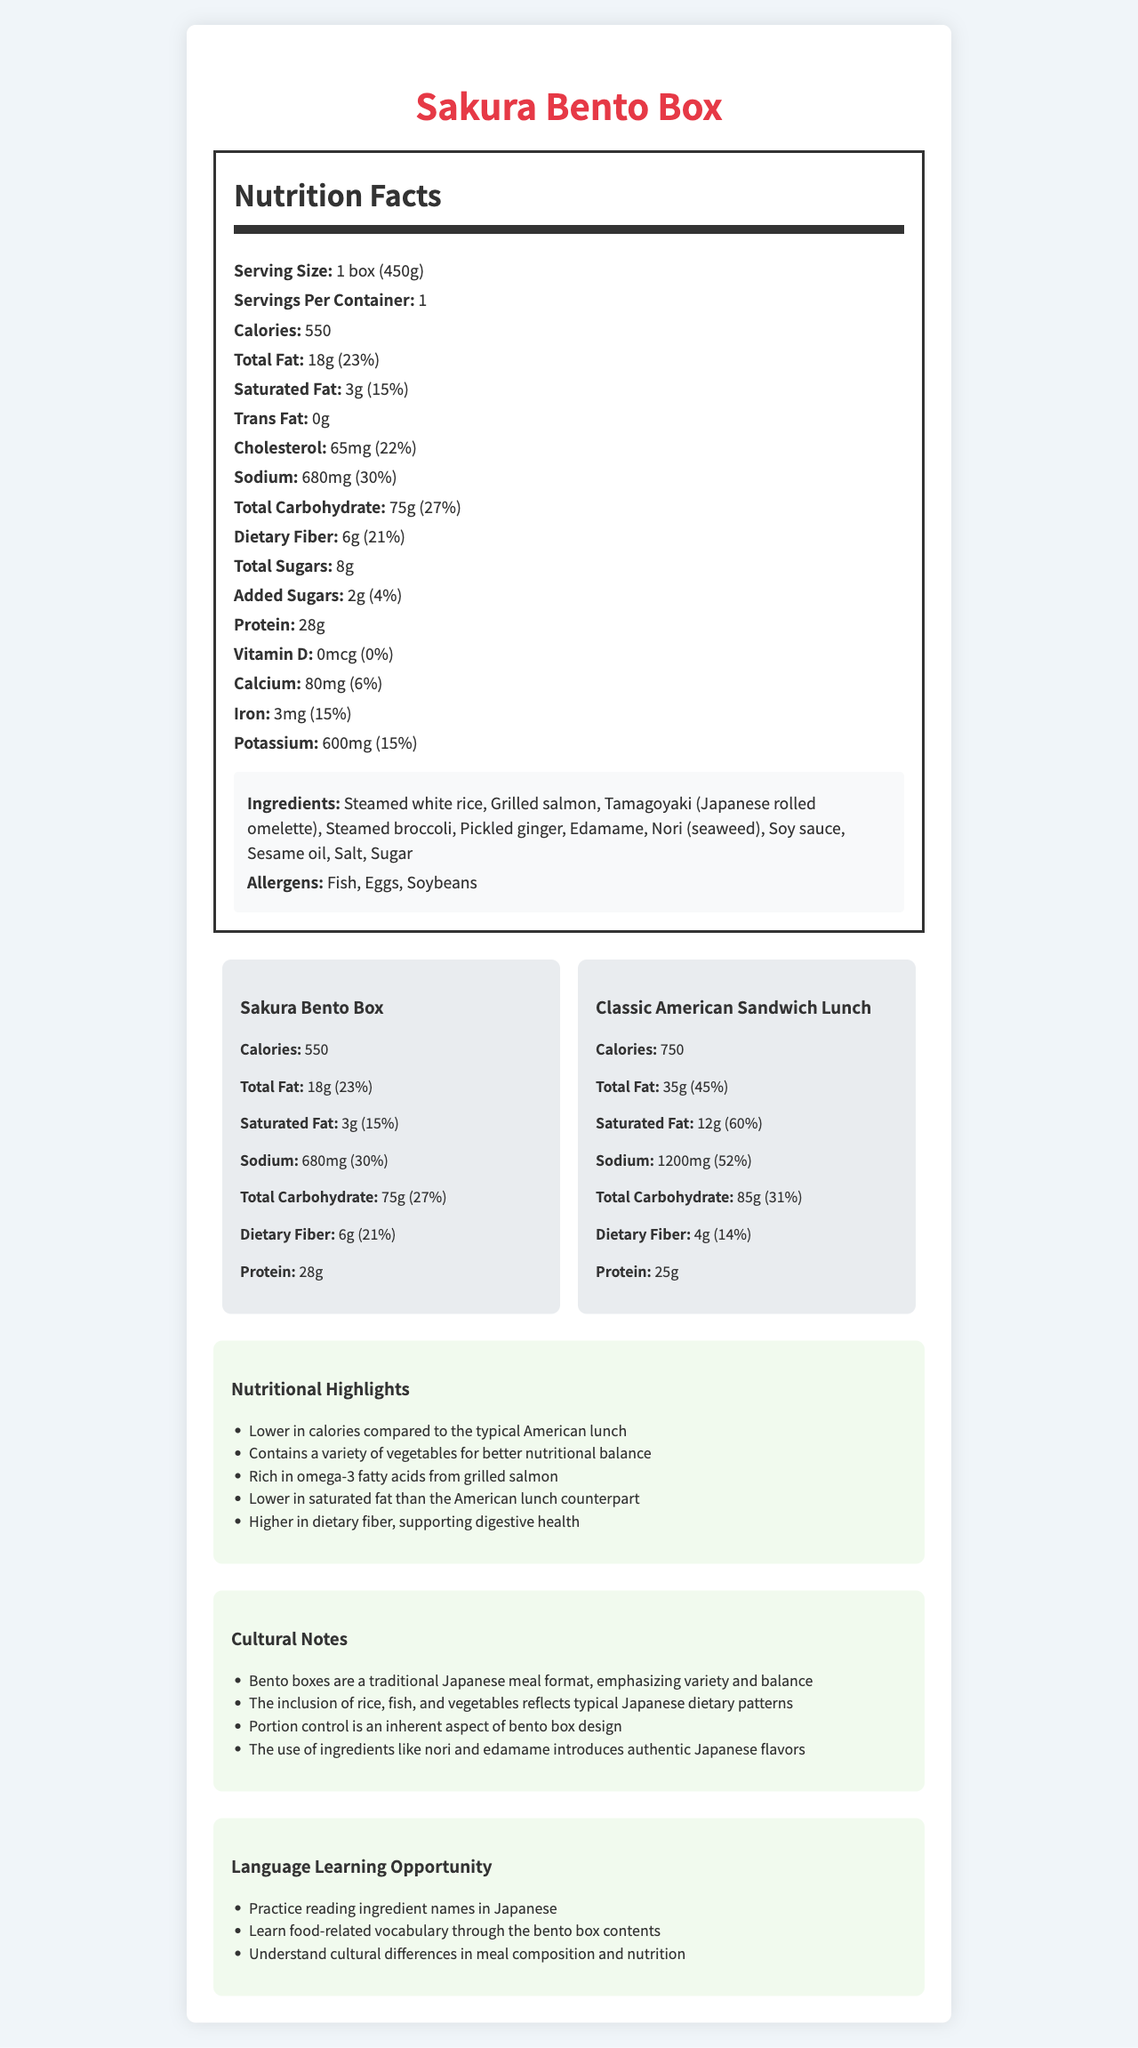what is the serving size of the Sakura Bento Box? The serving size is explicitly mentioned as "1 box (450g)" in the document.
Answer: 1 box (450g) how many calories does the Sakura Bento Box contain? The calories for the Sakura Bento Box are listed as 550 in the Nutrition Facts section.
Answer: 550 what is the protein content in the Sakura Bento Box? The protein content of the Sakura Bento Box is specified as 28g.
Answer: 28g list all the allergens present in the Sakura Bento Box. The allergens listed for the Sakura Bento Box are Fish, Eggs, and Soybeans.
Answer: Fish, Eggs, Soybeans how much dietary fiber does the Sakura Bento Box have? The dietary fiber content is given as 6g.
Answer: 6g compare the calories of Sahara Bento Box with the Classic American Sandwich Lunch. Which one contains fewer calories and by how much? The Sakura Bento Box has 550 calories, whereas the Classic American Sandwich Lunch has 750 calories. The difference is 200 calories.
Answer: Sakura Bento Box contains fewer calories by 200 calories how much sodium does the Classic American Sandwich Lunch contain? The sodium content for the Classic American Sandwich Lunch is listed as 1200mg.
Answer: 1200mg which meal has a higher amount of saturated fat, Sakura Bento Box or Classic American Sandwich Lunch? The Classic American Sandwich Lunch contains 12g of saturated fat compared to the 3g in the Sakura Bento Box.
Answer: Classic American Sandwich Lunch what are some of the ingredients in the Sakura Bento Box? The ingredients are listed under the ingredients section in the document.
Answer: Steamed white rice, Grilled salmon, Tamagoyaki (Japanese rolled omelette), Steamed broccoli, Pickled ginger, Edamame, Nori (seaweed), Soy sauce, Sesame oil, Salt, Sugar which meal has a higher dietary fiber content, the Sakura Bento Box or the Classic American Sandwich Lunch? The Sakura Bento Box has 6g of dietary fiber while the Classic American Sandwich Lunch has 4g of dietary fiber.
Answer: Sakura Bento Box does the Sakura Bento Box contain any trans fat? The document specifies that there is 0g of trans fat in the Sakura Bento Box.
Answer: No how much iron is present in the Sakura Bento Box in terms of daily value percentage? The iron amount is indicated as 15% of the daily value.
Answer: 15% which product contains more total fat? A. Sakura Bento Box B. Classic American Sandwich Lunch The Sakura Bento Box contains 18g of total fat, while the Classic American Sandwich Lunch contains 35g.
Answer: B which meal has a higher sodium daily value percentage? I. Sakura Bento Box II. Classic American Sandwich Lunch The Sakura Bento Box has a sodium daily value percentage of 30%, while the Classic American Sandwich Lunch has 52%.
Answer: II does the bento box contain any vitamin D? The Vitamin D content is listed as 0mcg with a 0% daily value in the document.
Answer: No summarize the main idea of the document. The document includes nutritional facts, ingredients, allergens, comparisons with an American lunch, nutritional highlights, cultural notes, and language learning opportunities associated with the Sakura Bento Box.
Answer: The document provides a detailed nutritional analysis of the Sakura Bento Box, a traditional Japanese meal, comparing it with a Classic American Sandwich Lunch. It highlights the lower calories, lower saturated fat, and higher dietary fiber content of the bento box. It also mentions its cultural significance and the language learning opportunities it offers. what is the percentage of daily value for calcium in the Classic American Sandwich Lunch? The document does not provide the daily value percentage for calcium in the Classic American Sandwich Lunch.
Answer: Not enough information 